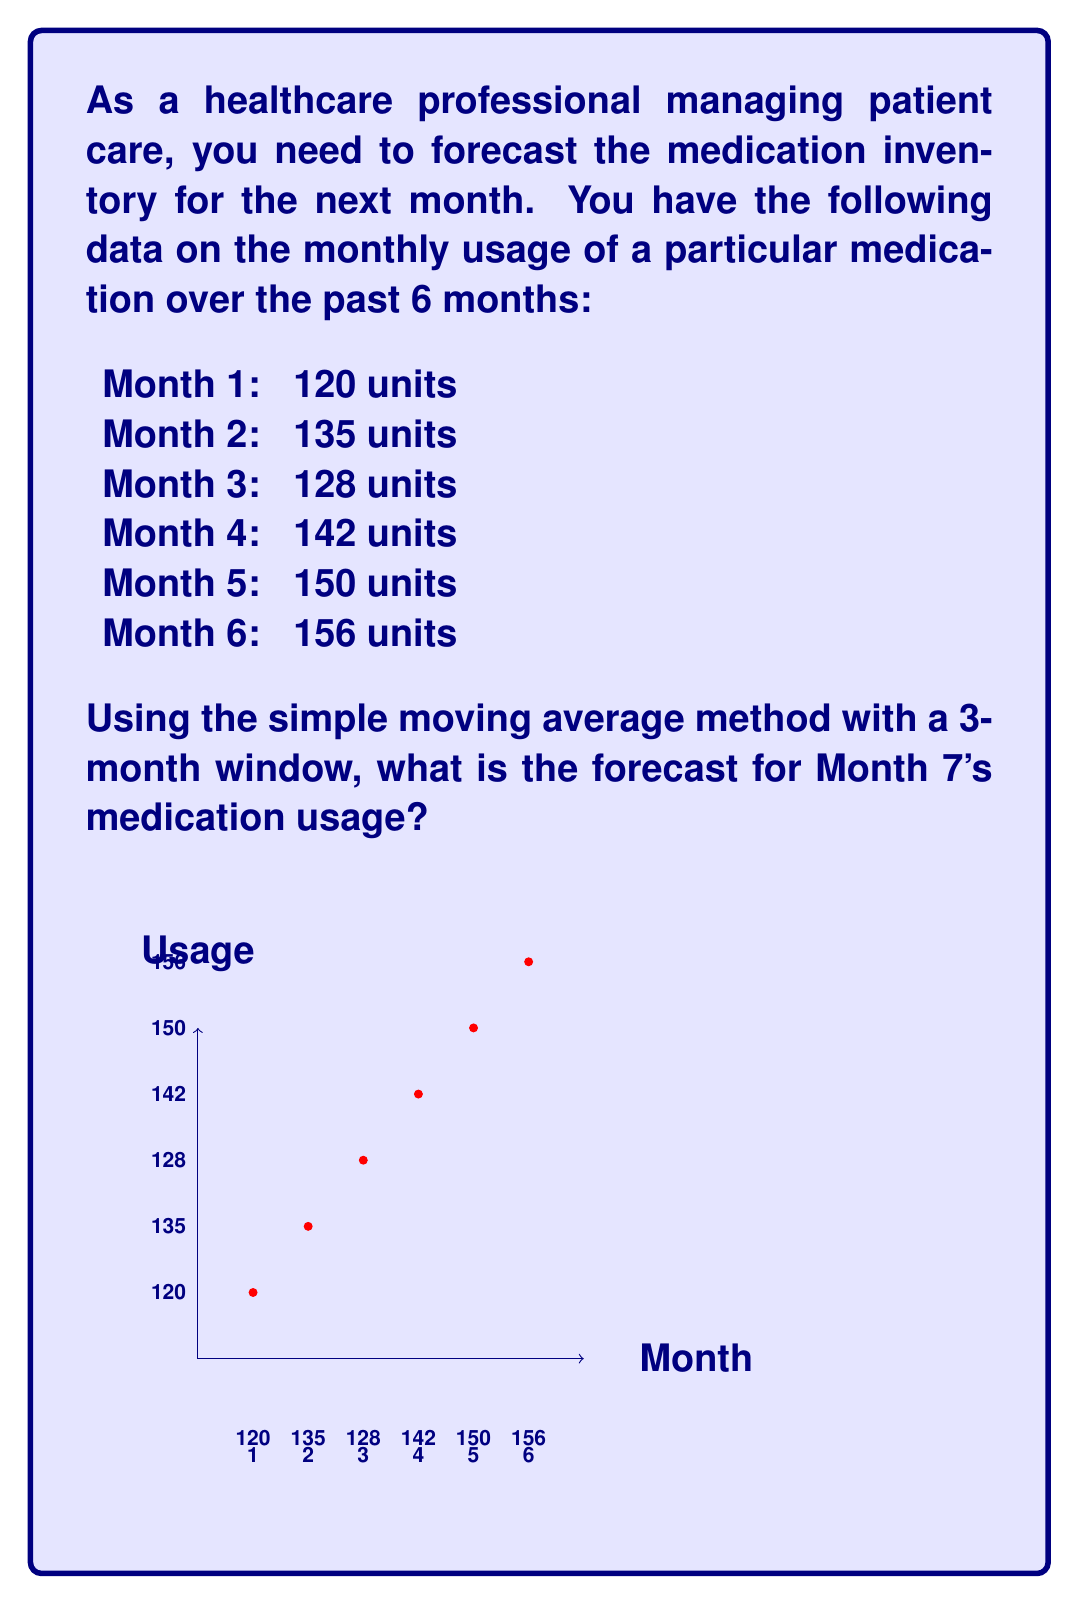Provide a solution to this math problem. To forecast the medication usage for Month 7 using the simple moving average method with a 3-month window, we follow these steps:

1) First, we need to calculate the average of the last 3 months (Months 4, 5, and 6).

2) The formula for the simple moving average is:

   $$SMA = \frac{\sum_{i=1}^{n} x_i}{n}$$

   Where $x_i$ are the values in the moving average window and $n$ is the number of values (in this case, 3).

3) Let's substitute the values:

   $$SMA = \frac{142 + 150 + 156}{3}$$

4) Calculating:

   $$SMA = \frac{448}{3} = 149.33$$

5) Rounding to the nearest whole number (as we can't dispense partial units of medication):

   $$SMA \approx 149$$

Therefore, based on the simple moving average method, we forecast that 149 units of the medication will be used in Month 7.
Answer: 149 units 